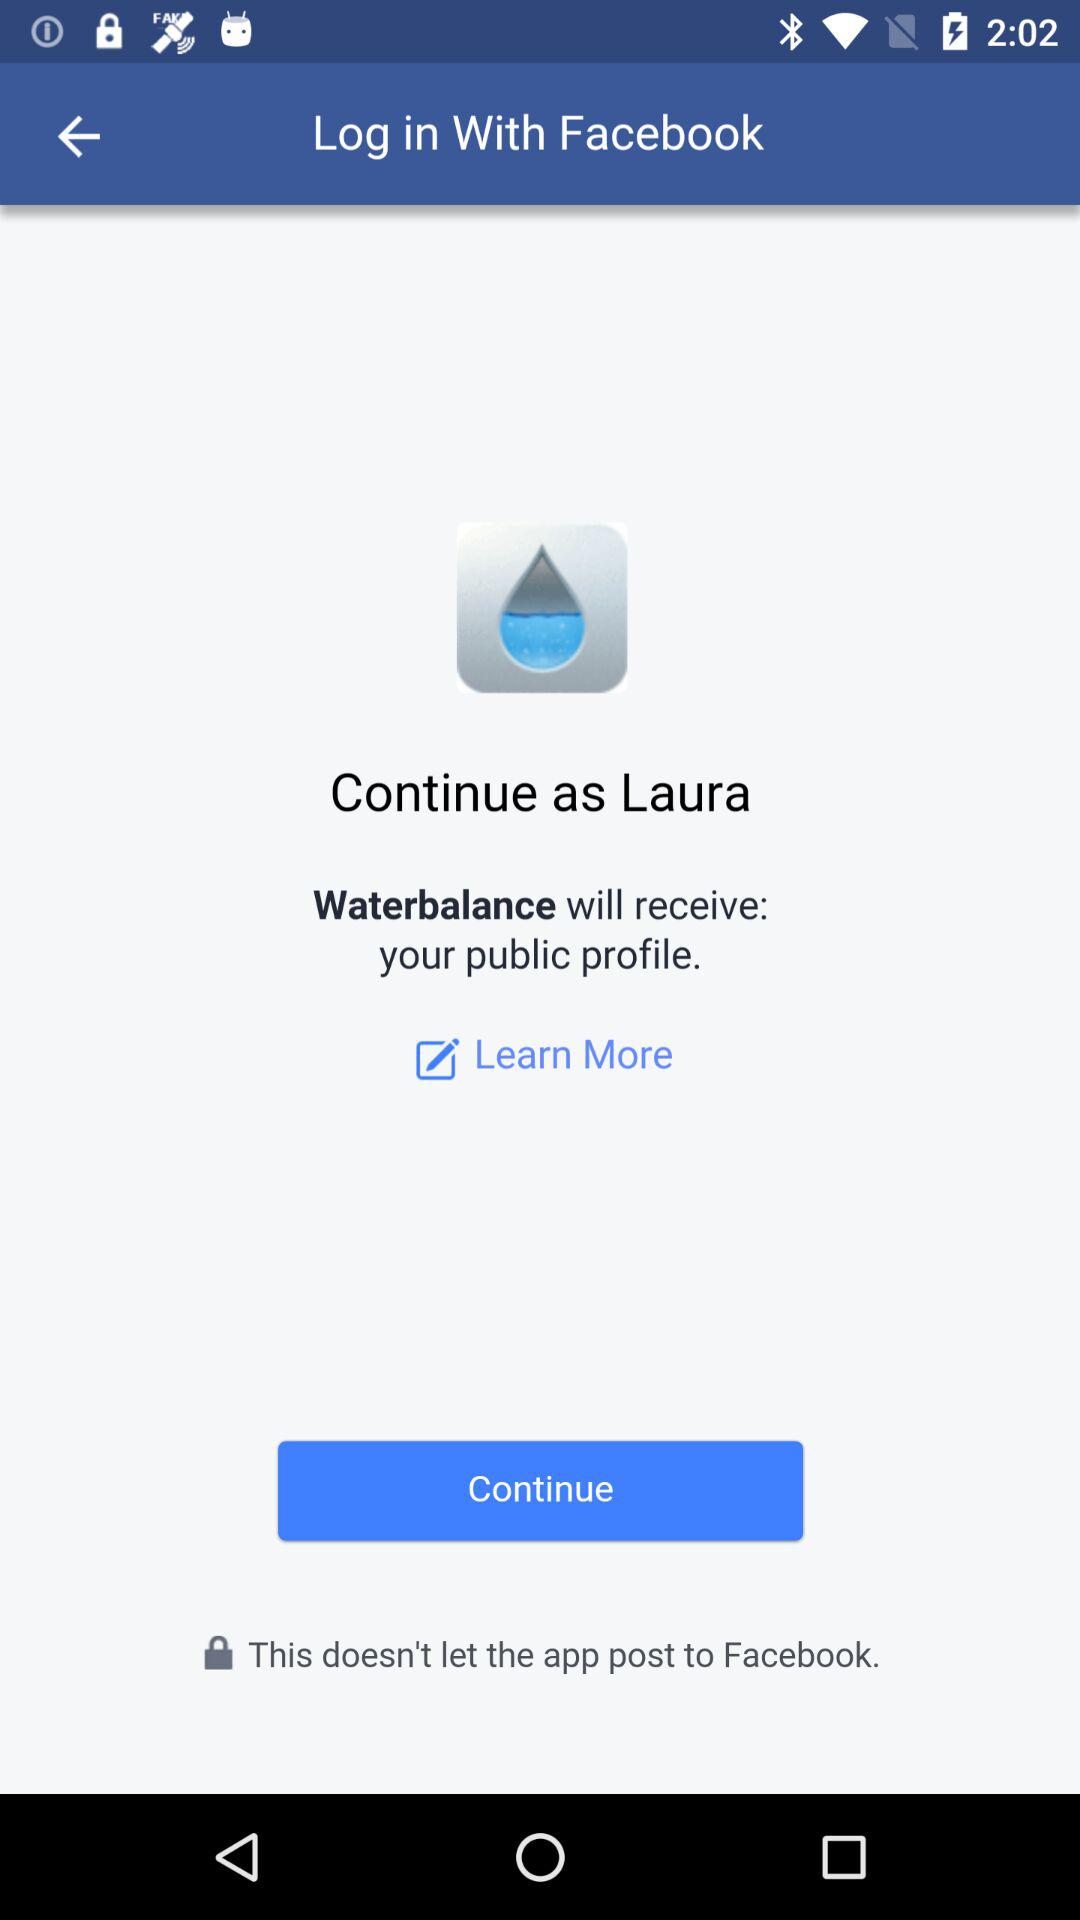Who will receive the public profile? The application that will receive the public profile is "Waterbalance". 